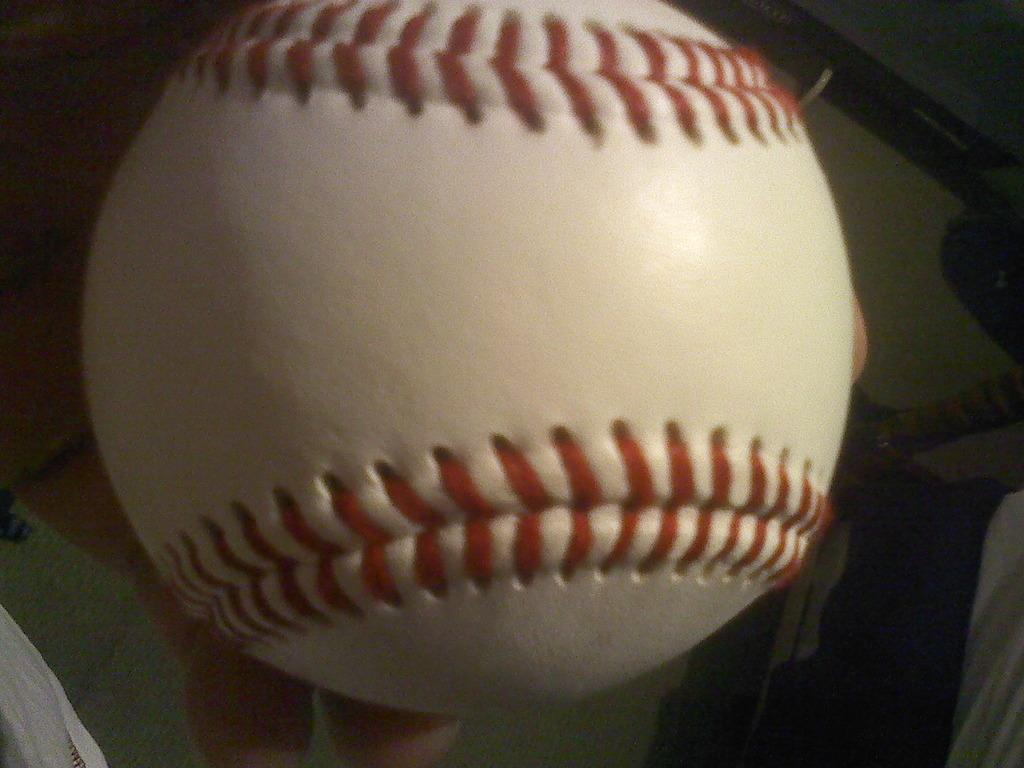What is being held by the hand in the image? The hand is holding a ball. Can you describe the appearance of the ball? The ball is white and red in color. What else can be seen in the image besides the hand and the ball? There are other objects visible in the background of the image. What type of berry is being played in the background of the image? There is no berry being played in the image; it features a hand holding a white and red ball. What question is being asked by the person holding the ball in the image? There is no person asking a question in the image; it only shows a hand holding a ball. 